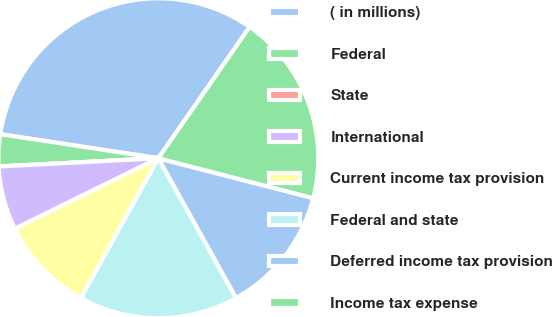Convert chart. <chart><loc_0><loc_0><loc_500><loc_500><pie_chart><fcel>( in millions)<fcel>Federal<fcel>State<fcel>International<fcel>Current income tax provision<fcel>Federal and state<fcel>Deferred income tax provision<fcel>Income tax expense<nl><fcel>32.26%<fcel>3.23%<fcel>0.0%<fcel>6.45%<fcel>9.68%<fcel>16.13%<fcel>12.9%<fcel>19.35%<nl></chart> 